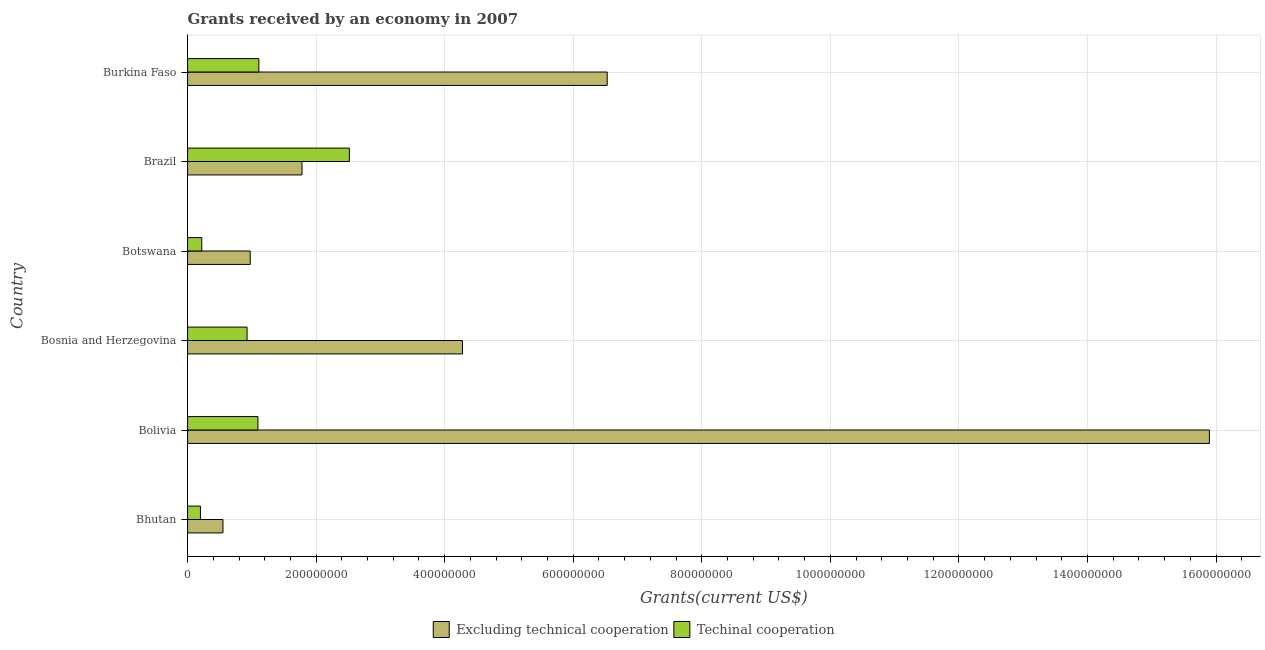How many different coloured bars are there?
Provide a short and direct response. 2. How many groups of bars are there?
Your answer should be very brief. 6. Are the number of bars on each tick of the Y-axis equal?
Make the answer very short. Yes. How many bars are there on the 6th tick from the top?
Your response must be concise. 2. What is the label of the 1st group of bars from the top?
Provide a succinct answer. Burkina Faso. In how many cases, is the number of bars for a given country not equal to the number of legend labels?
Your response must be concise. 0. What is the amount of grants received(including technical cooperation) in Botswana?
Your answer should be compact. 2.21e+07. Across all countries, what is the maximum amount of grants received(excluding technical cooperation)?
Your response must be concise. 1.59e+09. Across all countries, what is the minimum amount of grants received(excluding technical cooperation)?
Offer a terse response. 5.50e+07. In which country was the amount of grants received(including technical cooperation) maximum?
Your answer should be compact. Brazil. In which country was the amount of grants received(including technical cooperation) minimum?
Ensure brevity in your answer.  Bhutan. What is the total amount of grants received(including technical cooperation) in the graph?
Provide a succinct answer. 6.07e+08. What is the difference between the amount of grants received(including technical cooperation) in Bolivia and that in Bosnia and Herzegovina?
Give a very brief answer. 1.69e+07. What is the difference between the amount of grants received(excluding technical cooperation) in Brazil and the amount of grants received(including technical cooperation) in Bolivia?
Offer a terse response. 6.86e+07. What is the average amount of grants received(including technical cooperation) per country?
Offer a very short reply. 1.01e+08. What is the difference between the amount of grants received(including technical cooperation) and amount of grants received(excluding technical cooperation) in Brazil?
Your answer should be compact. 7.37e+07. What is the ratio of the amount of grants received(excluding technical cooperation) in Bosnia and Herzegovina to that in Burkina Faso?
Provide a short and direct response. 0.66. Is the amount of grants received(excluding technical cooperation) in Botswana less than that in Brazil?
Provide a succinct answer. Yes. Is the difference between the amount of grants received(excluding technical cooperation) in Brazil and Burkina Faso greater than the difference between the amount of grants received(including technical cooperation) in Brazil and Burkina Faso?
Offer a terse response. No. What is the difference between the highest and the second highest amount of grants received(including technical cooperation)?
Offer a terse response. 1.41e+08. What is the difference between the highest and the lowest amount of grants received(including technical cooperation)?
Provide a succinct answer. 2.32e+08. Is the sum of the amount of grants received(including technical cooperation) in Bolivia and Botswana greater than the maximum amount of grants received(excluding technical cooperation) across all countries?
Provide a short and direct response. No. What does the 2nd bar from the top in Bolivia represents?
Make the answer very short. Excluding technical cooperation. What does the 1st bar from the bottom in Bhutan represents?
Ensure brevity in your answer.  Excluding technical cooperation. How many bars are there?
Offer a terse response. 12. Are all the bars in the graph horizontal?
Give a very brief answer. Yes. How are the legend labels stacked?
Your answer should be compact. Horizontal. What is the title of the graph?
Provide a short and direct response. Grants received by an economy in 2007. Does "External balance on goods" appear as one of the legend labels in the graph?
Give a very brief answer. No. What is the label or title of the X-axis?
Keep it short and to the point. Grants(current US$). What is the Grants(current US$) of Excluding technical cooperation in Bhutan?
Provide a short and direct response. 5.50e+07. What is the Grants(current US$) in Techinal cooperation in Bhutan?
Offer a terse response. 2.00e+07. What is the Grants(current US$) of Excluding technical cooperation in Bolivia?
Keep it short and to the point. 1.59e+09. What is the Grants(current US$) of Techinal cooperation in Bolivia?
Make the answer very short. 1.09e+08. What is the Grants(current US$) in Excluding technical cooperation in Bosnia and Herzegovina?
Your response must be concise. 4.28e+08. What is the Grants(current US$) in Techinal cooperation in Bosnia and Herzegovina?
Ensure brevity in your answer.  9.25e+07. What is the Grants(current US$) in Excluding technical cooperation in Botswana?
Provide a short and direct response. 9.75e+07. What is the Grants(current US$) in Techinal cooperation in Botswana?
Make the answer very short. 2.21e+07. What is the Grants(current US$) of Excluding technical cooperation in Brazil?
Ensure brevity in your answer.  1.78e+08. What is the Grants(current US$) of Techinal cooperation in Brazil?
Give a very brief answer. 2.52e+08. What is the Grants(current US$) of Excluding technical cooperation in Burkina Faso?
Provide a short and direct response. 6.53e+08. What is the Grants(current US$) of Techinal cooperation in Burkina Faso?
Make the answer very short. 1.11e+08. Across all countries, what is the maximum Grants(current US$) of Excluding technical cooperation?
Give a very brief answer. 1.59e+09. Across all countries, what is the maximum Grants(current US$) of Techinal cooperation?
Provide a succinct answer. 2.52e+08. Across all countries, what is the minimum Grants(current US$) of Excluding technical cooperation?
Keep it short and to the point. 5.50e+07. What is the total Grants(current US$) in Excluding technical cooperation in the graph?
Provide a succinct answer. 3.00e+09. What is the total Grants(current US$) of Techinal cooperation in the graph?
Your answer should be compact. 6.07e+08. What is the difference between the Grants(current US$) of Excluding technical cooperation in Bhutan and that in Bolivia?
Ensure brevity in your answer.  -1.53e+09. What is the difference between the Grants(current US$) of Techinal cooperation in Bhutan and that in Bolivia?
Offer a very short reply. -8.94e+07. What is the difference between the Grants(current US$) of Excluding technical cooperation in Bhutan and that in Bosnia and Herzegovina?
Give a very brief answer. -3.73e+08. What is the difference between the Grants(current US$) in Techinal cooperation in Bhutan and that in Bosnia and Herzegovina?
Your answer should be very brief. -7.25e+07. What is the difference between the Grants(current US$) of Excluding technical cooperation in Bhutan and that in Botswana?
Make the answer very short. -4.25e+07. What is the difference between the Grants(current US$) of Techinal cooperation in Bhutan and that in Botswana?
Offer a terse response. -2.06e+06. What is the difference between the Grants(current US$) of Excluding technical cooperation in Bhutan and that in Brazil?
Your response must be concise. -1.23e+08. What is the difference between the Grants(current US$) in Techinal cooperation in Bhutan and that in Brazil?
Offer a terse response. -2.32e+08. What is the difference between the Grants(current US$) in Excluding technical cooperation in Bhutan and that in Burkina Faso?
Make the answer very short. -5.98e+08. What is the difference between the Grants(current US$) in Techinal cooperation in Bhutan and that in Burkina Faso?
Ensure brevity in your answer.  -9.09e+07. What is the difference between the Grants(current US$) of Excluding technical cooperation in Bolivia and that in Bosnia and Herzegovina?
Your response must be concise. 1.16e+09. What is the difference between the Grants(current US$) in Techinal cooperation in Bolivia and that in Bosnia and Herzegovina?
Your response must be concise. 1.69e+07. What is the difference between the Grants(current US$) in Excluding technical cooperation in Bolivia and that in Botswana?
Keep it short and to the point. 1.49e+09. What is the difference between the Grants(current US$) of Techinal cooperation in Bolivia and that in Botswana?
Give a very brief answer. 8.74e+07. What is the difference between the Grants(current US$) in Excluding technical cooperation in Bolivia and that in Brazil?
Provide a succinct answer. 1.41e+09. What is the difference between the Grants(current US$) of Techinal cooperation in Bolivia and that in Brazil?
Keep it short and to the point. -1.42e+08. What is the difference between the Grants(current US$) in Excluding technical cooperation in Bolivia and that in Burkina Faso?
Make the answer very short. 9.37e+08. What is the difference between the Grants(current US$) of Techinal cooperation in Bolivia and that in Burkina Faso?
Give a very brief answer. -1.46e+06. What is the difference between the Grants(current US$) in Excluding technical cooperation in Bosnia and Herzegovina and that in Botswana?
Provide a short and direct response. 3.30e+08. What is the difference between the Grants(current US$) in Techinal cooperation in Bosnia and Herzegovina and that in Botswana?
Ensure brevity in your answer.  7.05e+07. What is the difference between the Grants(current US$) of Excluding technical cooperation in Bosnia and Herzegovina and that in Brazil?
Your response must be concise. 2.50e+08. What is the difference between the Grants(current US$) of Techinal cooperation in Bosnia and Herzegovina and that in Brazil?
Your answer should be very brief. -1.59e+08. What is the difference between the Grants(current US$) of Excluding technical cooperation in Bosnia and Herzegovina and that in Burkina Faso?
Give a very brief answer. -2.25e+08. What is the difference between the Grants(current US$) in Techinal cooperation in Bosnia and Herzegovina and that in Burkina Faso?
Keep it short and to the point. -1.84e+07. What is the difference between the Grants(current US$) of Excluding technical cooperation in Botswana and that in Brazil?
Provide a short and direct response. -8.05e+07. What is the difference between the Grants(current US$) in Techinal cooperation in Botswana and that in Brazil?
Your answer should be very brief. -2.30e+08. What is the difference between the Grants(current US$) of Excluding technical cooperation in Botswana and that in Burkina Faso?
Make the answer very short. -5.55e+08. What is the difference between the Grants(current US$) in Techinal cooperation in Botswana and that in Burkina Faso?
Your answer should be very brief. -8.88e+07. What is the difference between the Grants(current US$) in Excluding technical cooperation in Brazil and that in Burkina Faso?
Make the answer very short. -4.75e+08. What is the difference between the Grants(current US$) of Techinal cooperation in Brazil and that in Burkina Faso?
Keep it short and to the point. 1.41e+08. What is the difference between the Grants(current US$) in Excluding technical cooperation in Bhutan and the Grants(current US$) in Techinal cooperation in Bolivia?
Your answer should be compact. -5.44e+07. What is the difference between the Grants(current US$) of Excluding technical cooperation in Bhutan and the Grants(current US$) of Techinal cooperation in Bosnia and Herzegovina?
Keep it short and to the point. -3.75e+07. What is the difference between the Grants(current US$) in Excluding technical cooperation in Bhutan and the Grants(current US$) in Techinal cooperation in Botswana?
Your response must be concise. 3.29e+07. What is the difference between the Grants(current US$) of Excluding technical cooperation in Bhutan and the Grants(current US$) of Techinal cooperation in Brazil?
Provide a short and direct response. -1.97e+08. What is the difference between the Grants(current US$) in Excluding technical cooperation in Bhutan and the Grants(current US$) in Techinal cooperation in Burkina Faso?
Provide a short and direct response. -5.59e+07. What is the difference between the Grants(current US$) in Excluding technical cooperation in Bolivia and the Grants(current US$) in Techinal cooperation in Bosnia and Herzegovina?
Keep it short and to the point. 1.50e+09. What is the difference between the Grants(current US$) in Excluding technical cooperation in Bolivia and the Grants(current US$) in Techinal cooperation in Botswana?
Give a very brief answer. 1.57e+09. What is the difference between the Grants(current US$) of Excluding technical cooperation in Bolivia and the Grants(current US$) of Techinal cooperation in Brazil?
Your answer should be compact. 1.34e+09. What is the difference between the Grants(current US$) in Excluding technical cooperation in Bolivia and the Grants(current US$) in Techinal cooperation in Burkina Faso?
Provide a short and direct response. 1.48e+09. What is the difference between the Grants(current US$) of Excluding technical cooperation in Bosnia and Herzegovina and the Grants(current US$) of Techinal cooperation in Botswana?
Ensure brevity in your answer.  4.06e+08. What is the difference between the Grants(current US$) of Excluding technical cooperation in Bosnia and Herzegovina and the Grants(current US$) of Techinal cooperation in Brazil?
Your response must be concise. 1.76e+08. What is the difference between the Grants(current US$) in Excluding technical cooperation in Bosnia and Herzegovina and the Grants(current US$) in Techinal cooperation in Burkina Faso?
Your answer should be compact. 3.17e+08. What is the difference between the Grants(current US$) in Excluding technical cooperation in Botswana and the Grants(current US$) in Techinal cooperation in Brazil?
Offer a terse response. -1.54e+08. What is the difference between the Grants(current US$) of Excluding technical cooperation in Botswana and the Grants(current US$) of Techinal cooperation in Burkina Faso?
Offer a very short reply. -1.34e+07. What is the difference between the Grants(current US$) in Excluding technical cooperation in Brazil and the Grants(current US$) in Techinal cooperation in Burkina Faso?
Ensure brevity in your answer.  6.71e+07. What is the average Grants(current US$) of Excluding technical cooperation per country?
Offer a very short reply. 5.00e+08. What is the average Grants(current US$) in Techinal cooperation per country?
Your response must be concise. 1.01e+08. What is the difference between the Grants(current US$) in Excluding technical cooperation and Grants(current US$) in Techinal cooperation in Bhutan?
Make the answer very short. 3.50e+07. What is the difference between the Grants(current US$) of Excluding technical cooperation and Grants(current US$) of Techinal cooperation in Bolivia?
Ensure brevity in your answer.  1.48e+09. What is the difference between the Grants(current US$) in Excluding technical cooperation and Grants(current US$) in Techinal cooperation in Bosnia and Herzegovina?
Offer a terse response. 3.35e+08. What is the difference between the Grants(current US$) in Excluding technical cooperation and Grants(current US$) in Techinal cooperation in Botswana?
Your answer should be compact. 7.54e+07. What is the difference between the Grants(current US$) of Excluding technical cooperation and Grants(current US$) of Techinal cooperation in Brazil?
Make the answer very short. -7.37e+07. What is the difference between the Grants(current US$) of Excluding technical cooperation and Grants(current US$) of Techinal cooperation in Burkina Faso?
Give a very brief answer. 5.42e+08. What is the ratio of the Grants(current US$) in Excluding technical cooperation in Bhutan to that in Bolivia?
Give a very brief answer. 0.03. What is the ratio of the Grants(current US$) of Techinal cooperation in Bhutan to that in Bolivia?
Provide a short and direct response. 0.18. What is the ratio of the Grants(current US$) in Excluding technical cooperation in Bhutan to that in Bosnia and Herzegovina?
Make the answer very short. 0.13. What is the ratio of the Grants(current US$) in Techinal cooperation in Bhutan to that in Bosnia and Herzegovina?
Offer a very short reply. 0.22. What is the ratio of the Grants(current US$) in Excluding technical cooperation in Bhutan to that in Botswana?
Make the answer very short. 0.56. What is the ratio of the Grants(current US$) in Techinal cooperation in Bhutan to that in Botswana?
Give a very brief answer. 0.91. What is the ratio of the Grants(current US$) of Excluding technical cooperation in Bhutan to that in Brazil?
Keep it short and to the point. 0.31. What is the ratio of the Grants(current US$) of Techinal cooperation in Bhutan to that in Brazil?
Ensure brevity in your answer.  0.08. What is the ratio of the Grants(current US$) in Excluding technical cooperation in Bhutan to that in Burkina Faso?
Ensure brevity in your answer.  0.08. What is the ratio of the Grants(current US$) in Techinal cooperation in Bhutan to that in Burkina Faso?
Provide a short and direct response. 0.18. What is the ratio of the Grants(current US$) in Excluding technical cooperation in Bolivia to that in Bosnia and Herzegovina?
Provide a succinct answer. 3.72. What is the ratio of the Grants(current US$) in Techinal cooperation in Bolivia to that in Bosnia and Herzegovina?
Give a very brief answer. 1.18. What is the ratio of the Grants(current US$) in Excluding technical cooperation in Bolivia to that in Botswana?
Your response must be concise. 16.31. What is the ratio of the Grants(current US$) in Techinal cooperation in Bolivia to that in Botswana?
Your answer should be compact. 4.96. What is the ratio of the Grants(current US$) in Excluding technical cooperation in Bolivia to that in Brazil?
Provide a succinct answer. 8.93. What is the ratio of the Grants(current US$) of Techinal cooperation in Bolivia to that in Brazil?
Your answer should be compact. 0.43. What is the ratio of the Grants(current US$) of Excluding technical cooperation in Bolivia to that in Burkina Faso?
Keep it short and to the point. 2.44. What is the ratio of the Grants(current US$) in Techinal cooperation in Bolivia to that in Burkina Faso?
Offer a very short reply. 0.99. What is the ratio of the Grants(current US$) in Excluding technical cooperation in Bosnia and Herzegovina to that in Botswana?
Give a very brief answer. 4.39. What is the ratio of the Grants(current US$) of Techinal cooperation in Bosnia and Herzegovina to that in Botswana?
Provide a succinct answer. 4.19. What is the ratio of the Grants(current US$) of Excluding technical cooperation in Bosnia and Herzegovina to that in Brazil?
Provide a succinct answer. 2.4. What is the ratio of the Grants(current US$) of Techinal cooperation in Bosnia and Herzegovina to that in Brazil?
Keep it short and to the point. 0.37. What is the ratio of the Grants(current US$) in Excluding technical cooperation in Bosnia and Herzegovina to that in Burkina Faso?
Give a very brief answer. 0.66. What is the ratio of the Grants(current US$) in Techinal cooperation in Bosnia and Herzegovina to that in Burkina Faso?
Your response must be concise. 0.83. What is the ratio of the Grants(current US$) of Excluding technical cooperation in Botswana to that in Brazil?
Make the answer very short. 0.55. What is the ratio of the Grants(current US$) in Techinal cooperation in Botswana to that in Brazil?
Offer a very short reply. 0.09. What is the ratio of the Grants(current US$) of Excluding technical cooperation in Botswana to that in Burkina Faso?
Make the answer very short. 0.15. What is the ratio of the Grants(current US$) of Techinal cooperation in Botswana to that in Burkina Faso?
Offer a very short reply. 0.2. What is the ratio of the Grants(current US$) in Excluding technical cooperation in Brazil to that in Burkina Faso?
Provide a short and direct response. 0.27. What is the ratio of the Grants(current US$) of Techinal cooperation in Brazil to that in Burkina Faso?
Offer a terse response. 2.27. What is the difference between the highest and the second highest Grants(current US$) in Excluding technical cooperation?
Give a very brief answer. 9.37e+08. What is the difference between the highest and the second highest Grants(current US$) of Techinal cooperation?
Offer a very short reply. 1.41e+08. What is the difference between the highest and the lowest Grants(current US$) in Excluding technical cooperation?
Provide a succinct answer. 1.53e+09. What is the difference between the highest and the lowest Grants(current US$) in Techinal cooperation?
Offer a very short reply. 2.32e+08. 